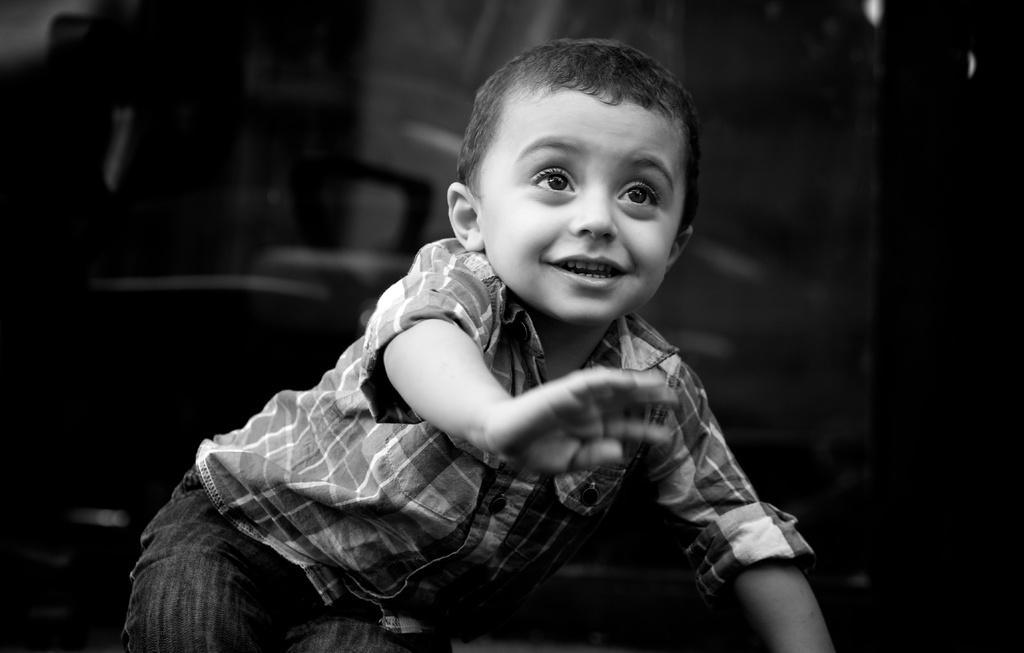What is the color scheme of the image? The image is black and white. Who or what is the main subject in the image? There is a boy in the image. Can you describe the background of the image? The background behind the boy is blurred. What type of shoe is the boy wearing in the image? There is no shoe visible in the image, as it is black and white and only features a boy with a blurred background. 